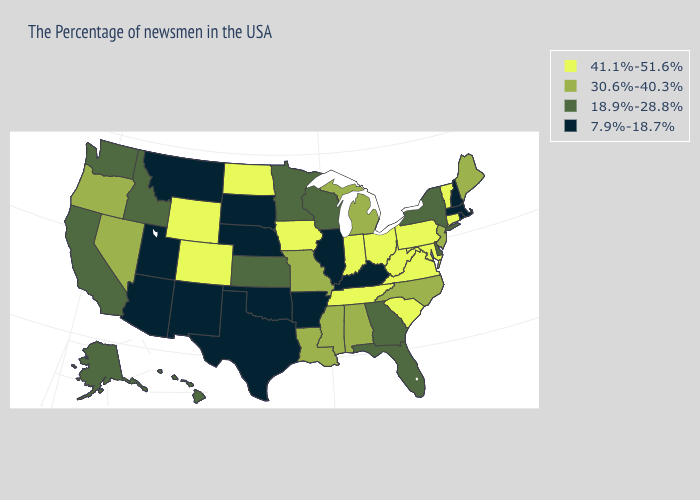What is the highest value in the USA?
Be succinct. 41.1%-51.6%. What is the highest value in the USA?
Give a very brief answer. 41.1%-51.6%. Name the states that have a value in the range 18.9%-28.8%?
Concise answer only. New York, Delaware, Florida, Georgia, Wisconsin, Minnesota, Kansas, Idaho, California, Washington, Alaska, Hawaii. Name the states that have a value in the range 41.1%-51.6%?
Concise answer only. Vermont, Connecticut, Maryland, Pennsylvania, Virginia, South Carolina, West Virginia, Ohio, Indiana, Tennessee, Iowa, North Dakota, Wyoming, Colorado. What is the value of Louisiana?
Quick response, please. 30.6%-40.3%. Does Montana have the lowest value in the USA?
Be succinct. Yes. Among the states that border Utah , which have the lowest value?
Quick response, please. New Mexico, Arizona. Does the map have missing data?
Answer briefly. No. Which states have the highest value in the USA?
Short answer required. Vermont, Connecticut, Maryland, Pennsylvania, Virginia, South Carolina, West Virginia, Ohio, Indiana, Tennessee, Iowa, North Dakota, Wyoming, Colorado. Which states hav the highest value in the MidWest?
Answer briefly. Ohio, Indiana, Iowa, North Dakota. What is the value of Missouri?
Give a very brief answer. 30.6%-40.3%. Name the states that have a value in the range 41.1%-51.6%?
Short answer required. Vermont, Connecticut, Maryland, Pennsylvania, Virginia, South Carolina, West Virginia, Ohio, Indiana, Tennessee, Iowa, North Dakota, Wyoming, Colorado. What is the value of Minnesota?
Give a very brief answer. 18.9%-28.8%. Name the states that have a value in the range 41.1%-51.6%?
Short answer required. Vermont, Connecticut, Maryland, Pennsylvania, Virginia, South Carolina, West Virginia, Ohio, Indiana, Tennessee, Iowa, North Dakota, Wyoming, Colorado. What is the highest value in states that border New Jersey?
Give a very brief answer. 41.1%-51.6%. 